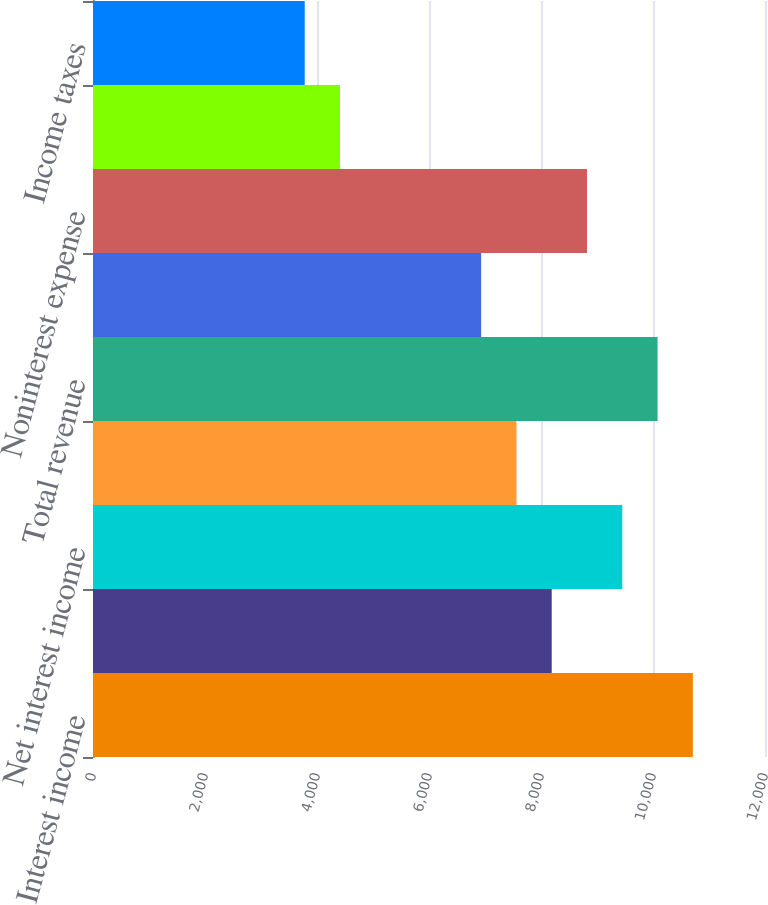Convert chart. <chart><loc_0><loc_0><loc_500><loc_500><bar_chart><fcel>Interest income<fcel>Interest expense<fcel>Net interest income<fcel>Noninterest income (b)<fcel>Total revenue<fcel>Provision for credit losses<fcel>Noninterest expense<fcel>Income from continuing<fcel>Income taxes<nl><fcel>10711.5<fcel>8191.25<fcel>9451.39<fcel>7561.18<fcel>10081.5<fcel>6931.11<fcel>8821.32<fcel>4410.83<fcel>3780.76<nl></chart> 